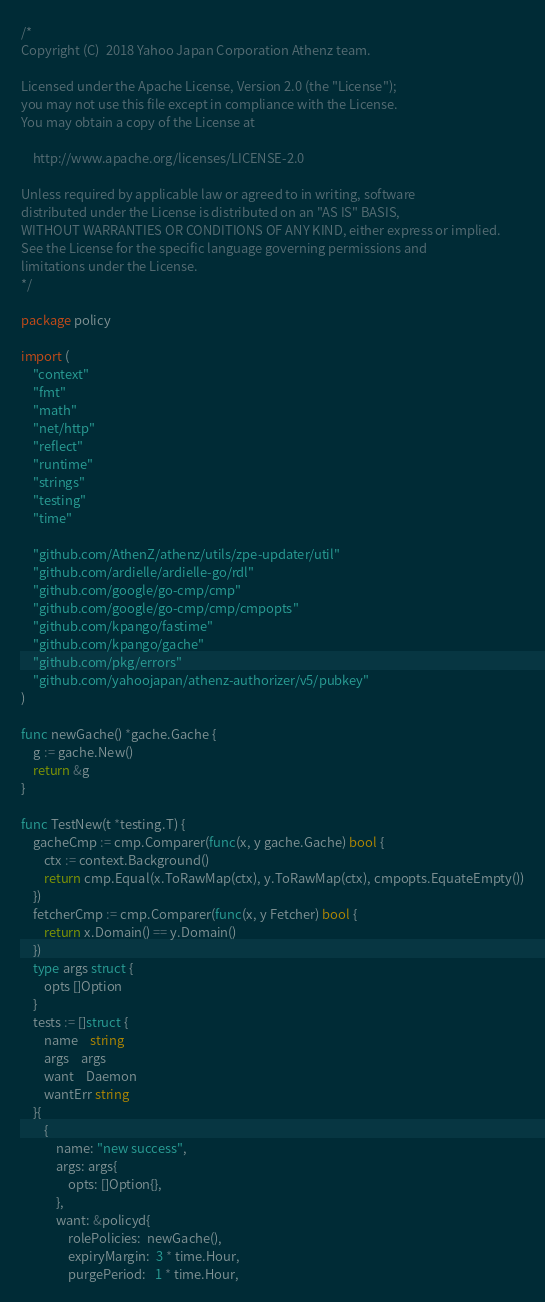<code> <loc_0><loc_0><loc_500><loc_500><_Go_>/*
Copyright (C)  2018 Yahoo Japan Corporation Athenz team.

Licensed under the Apache License, Version 2.0 (the "License");
you may not use this file except in compliance with the License.
You may obtain a copy of the License at

    http://www.apache.org/licenses/LICENSE-2.0

Unless required by applicable law or agreed to in writing, software
distributed under the License is distributed on an "AS IS" BASIS,
WITHOUT WARRANTIES OR CONDITIONS OF ANY KIND, either express or implied.
See the License for the specific language governing permissions and
limitations under the License.
*/

package policy

import (
	"context"
	"fmt"
	"math"
	"net/http"
	"reflect"
	"runtime"
	"strings"
	"testing"
	"time"

	"github.com/AthenZ/athenz/utils/zpe-updater/util"
	"github.com/ardielle/ardielle-go/rdl"
	"github.com/google/go-cmp/cmp"
	"github.com/google/go-cmp/cmp/cmpopts"
	"github.com/kpango/fastime"
	"github.com/kpango/gache"
	"github.com/pkg/errors"
	"github.com/yahoojapan/athenz-authorizer/v5/pubkey"
)

func newGache() *gache.Gache {
	g := gache.New()
	return &g
}

func TestNew(t *testing.T) {
	gacheCmp := cmp.Comparer(func(x, y gache.Gache) bool {
		ctx := context.Background()
		return cmp.Equal(x.ToRawMap(ctx), y.ToRawMap(ctx), cmpopts.EquateEmpty())
	})
	fetcherCmp := cmp.Comparer(func(x, y Fetcher) bool {
		return x.Domain() == y.Domain()
	})
	type args struct {
		opts []Option
	}
	tests := []struct {
		name    string
		args    args
		want    Daemon
		wantErr string
	}{
		{
			name: "new success",
			args: args{
				opts: []Option{},
			},
			want: &policyd{
				rolePolicies:  newGache(),
				expiryMargin:  3 * time.Hour,
				purgePeriod:   1 * time.Hour,</code> 